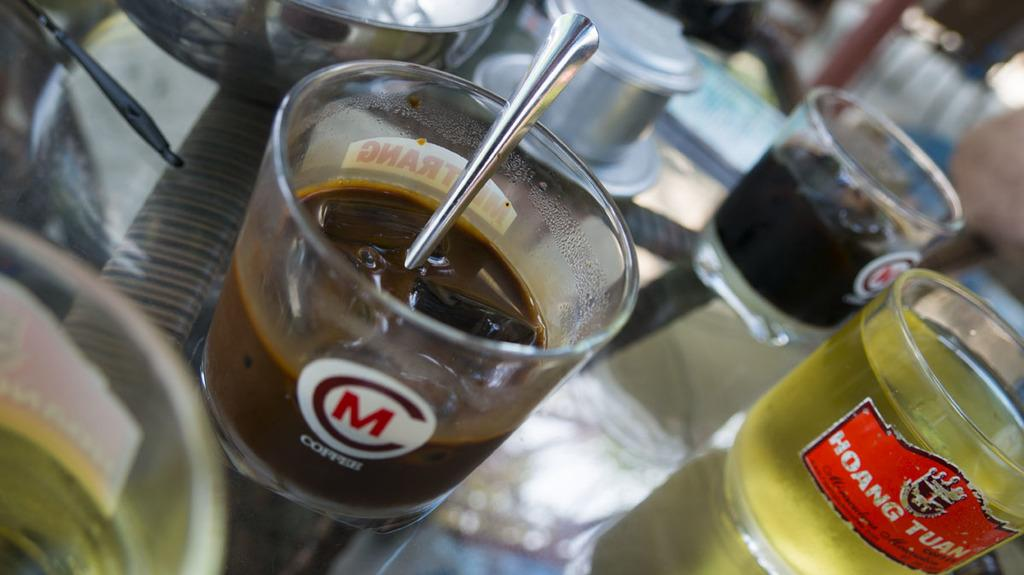Provide a one-sentence caption for the provided image. The word copper is on a glass with other glasses surrounding it. 